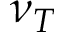<formula> <loc_0><loc_0><loc_500><loc_500>\nu _ { T }</formula> 